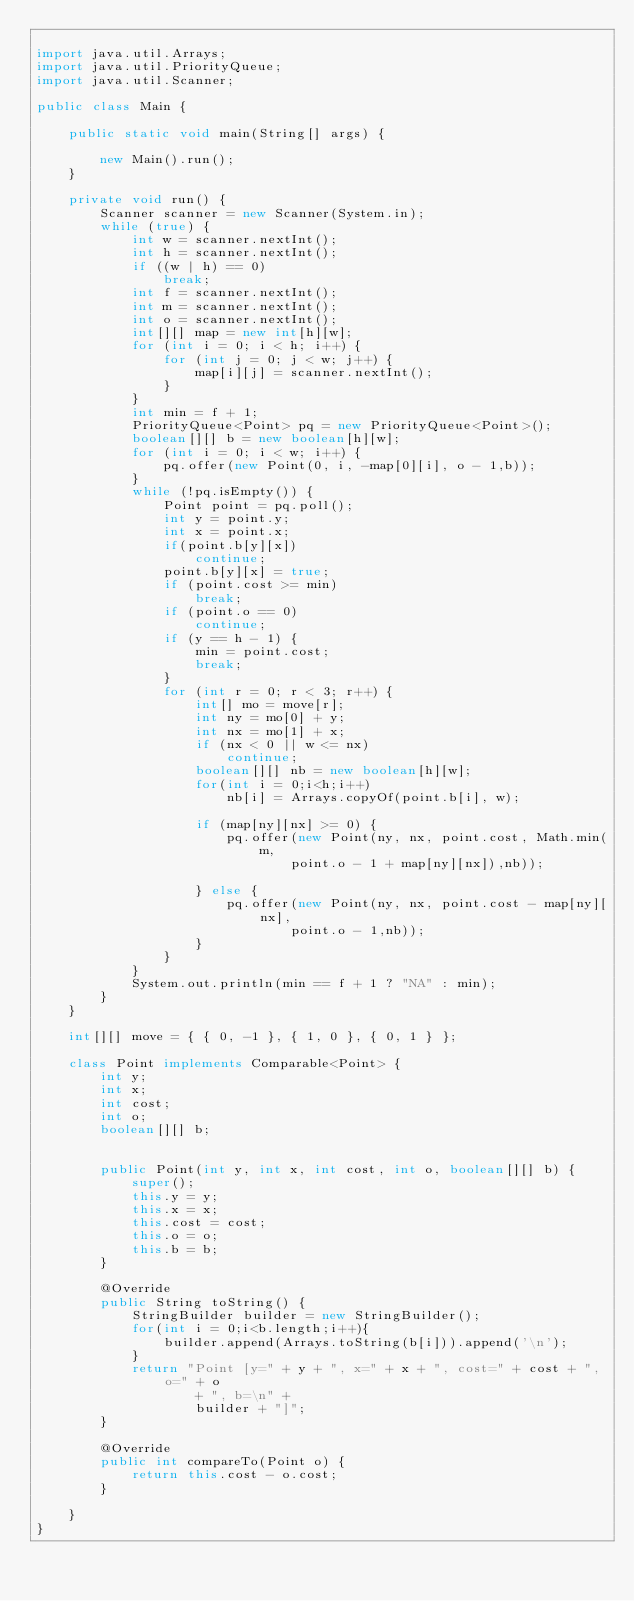Convert code to text. <code><loc_0><loc_0><loc_500><loc_500><_Java_>
import java.util.Arrays;
import java.util.PriorityQueue;
import java.util.Scanner;

public class Main {

	public static void main(String[] args) {

		new Main().run();
	}

	private void run() {
		Scanner scanner = new Scanner(System.in);
		while (true) {
			int w = scanner.nextInt();
			int h = scanner.nextInt();
			if ((w | h) == 0)
				break;
			int f = scanner.nextInt();
			int m = scanner.nextInt();
			int o = scanner.nextInt();
			int[][] map = new int[h][w];
			for (int i = 0; i < h; i++) {
				for (int j = 0; j < w; j++) {
					map[i][j] = scanner.nextInt();
				}
			}
			int min = f + 1;
			PriorityQueue<Point> pq = new PriorityQueue<Point>();
			boolean[][] b = new boolean[h][w];
			for (int i = 0; i < w; i++) {
				pq.offer(new Point(0, i, -map[0][i], o - 1,b));
			}
			while (!pq.isEmpty()) {
				Point point = pq.poll();
				int y = point.y;
				int x = point.x;
				if(point.b[y][x])
					continue;
				point.b[y][x] = true;
				if (point.cost >= min)
					break;
				if (point.o == 0)
					continue;
				if (y == h - 1) {
					min = point.cost;
					break;
				}
				for (int r = 0; r < 3; r++) {
					int[] mo = move[r];
					int ny = mo[0] + y;
					int nx = mo[1] + x;
					if (nx < 0 || w <= nx)
						continue;
					boolean[][] nb = new boolean[h][w];
					for(int i = 0;i<h;i++)
						nb[i] = Arrays.copyOf(point.b[i], w);
						
					if (map[ny][nx] >= 0) {
						pq.offer(new Point(ny, nx, point.cost, Math.min(m,
								point.o - 1 + map[ny][nx]),nb));

					} else {
						pq.offer(new Point(ny, nx, point.cost - map[ny][nx],
								point.o - 1,nb));
					}
				}
			}
			System.out.println(min == f + 1 ? "NA" : min);
		}
	}

	int[][] move = { { 0, -1 }, { 1, 0 }, { 0, 1 } };

	class Point implements Comparable<Point> {
		int y;
		int x;
		int cost;
		int o;
		boolean[][] b;


		public Point(int y, int x, int cost, int o, boolean[][] b) {
			super();
			this.y = y;
			this.x = x;
			this.cost = cost;
			this.o = o;
			this.b = b;
		}

		@Override
		public String toString() {
			StringBuilder builder = new StringBuilder();
			for(int i = 0;i<b.length;i++){
				builder.append(Arrays.toString(b[i])).append('\n');
			}
			return "Point [y=" + y + ", x=" + x + ", cost=" + cost + ", o=" + o
					+ ", b=\n" +
					builder + "]";
		}

		@Override
		public int compareTo(Point o) {
			return this.cost - o.cost;
		}

	}
}</code> 